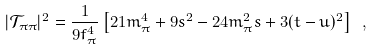<formula> <loc_0><loc_0><loc_500><loc_500>| \mathcal { T } _ { \pi \pi } | ^ { 2 } = \frac { 1 } { 9 f _ { \pi } ^ { 4 } } \left [ 2 1 m _ { \pi } ^ { 4 } + 9 s ^ { 2 } - 2 4 m _ { \pi } ^ { 2 } s + 3 ( t - u ) ^ { 2 } \right ] \ ,</formula> 